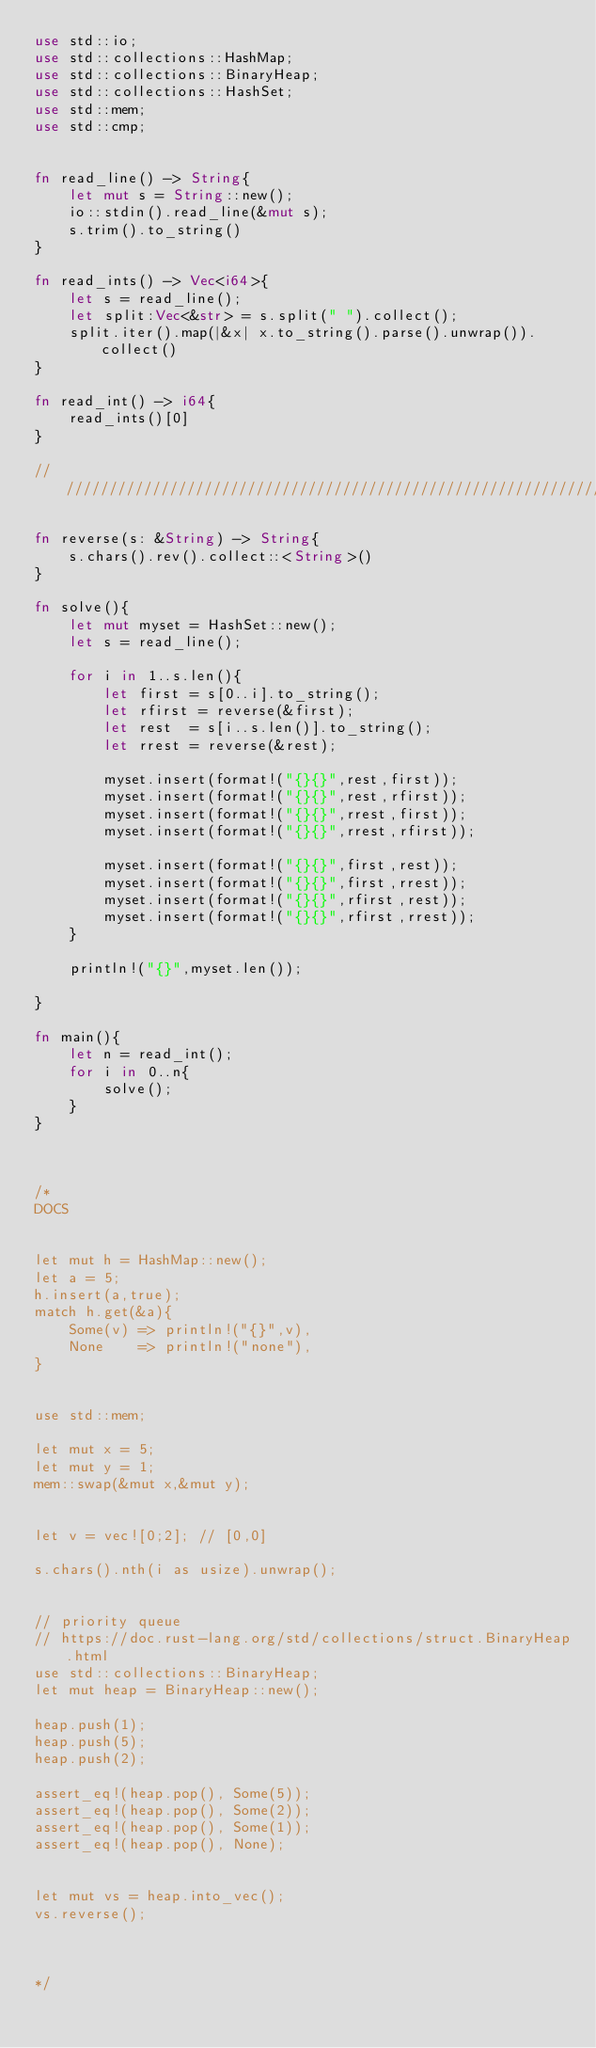<code> <loc_0><loc_0><loc_500><loc_500><_Rust_>use std::io;
use std::collections::HashMap;
use std::collections::BinaryHeap;
use std::collections::HashSet;
use std::mem;
use std::cmp;


fn read_line() -> String{
    let mut s = String::new();
    io::stdin().read_line(&mut s);
    s.trim().to_string()
}

fn read_ints() -> Vec<i64>{
    let s = read_line();
    let split:Vec<&str> = s.split(" ").collect();
    split.iter().map(|&x| x.to_string().parse().unwrap()).collect()
}

fn read_int() -> i64{
    read_ints()[0]
}

//////////////////////////////////////////////////////////////////////

fn reverse(s: &String) -> String{
    s.chars().rev().collect::<String>()
}

fn solve(){
    let mut myset = HashSet::new();
    let s = read_line();

    for i in 1..s.len(){
        let first = s[0..i].to_string();
        let rfirst = reverse(&first);
        let rest  = s[i..s.len()].to_string();
        let rrest = reverse(&rest);
        
        myset.insert(format!("{}{}",rest,first));
        myset.insert(format!("{}{}",rest,rfirst));
        myset.insert(format!("{}{}",rrest,first));
        myset.insert(format!("{}{}",rrest,rfirst));
        
        myset.insert(format!("{}{}",first,rest));
        myset.insert(format!("{}{}",first,rrest));
        myset.insert(format!("{}{}",rfirst,rest));
        myset.insert(format!("{}{}",rfirst,rrest));
    }
    
    println!("{}",myset.len());

}

fn main(){
    let n = read_int();
    for i in 0..n{
        solve();
    }
}



/*
DOCS


let mut h = HashMap::new();
let a = 5;
h.insert(a,true);
match h.get(&a){
    Some(v) => println!("{}",v),
    None    => println!("none"),
}


use std::mem;

let mut x = 5;
let mut y = 1;
mem::swap(&mut x,&mut y);


let v = vec![0;2]; // [0,0]

s.chars().nth(i as usize).unwrap();


// priority queue
// https://doc.rust-lang.org/std/collections/struct.BinaryHeap.html
use std::collections::BinaryHeap;
let mut heap = BinaryHeap::new();

heap.push(1);
heap.push(5);
heap.push(2);

assert_eq!(heap.pop(), Some(5));
assert_eq!(heap.pop(), Some(2));
assert_eq!(heap.pop(), Some(1));
assert_eq!(heap.pop(), None);


let mut vs = heap.into_vec();
vs.reverse();



*/

</code> 